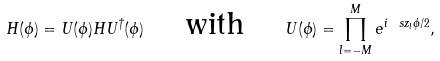<formula> <loc_0><loc_0><loc_500><loc_500>H ( \phi ) = U ( \phi ) H U ^ { \dag } ( \phi ) \quad \text { with } \quad U ( \phi ) = \prod _ { l = - M } ^ { M } e ^ { i \ s z _ { l } \phi / 2 } ,</formula> 